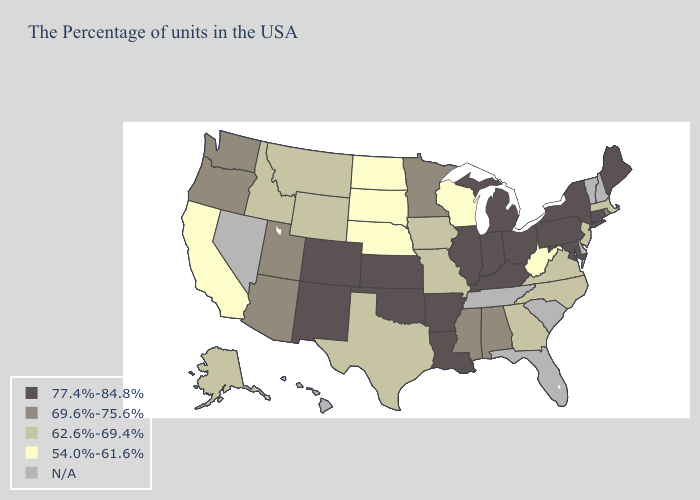Name the states that have a value in the range 77.4%-84.8%?
Short answer required. Maine, Connecticut, New York, Maryland, Pennsylvania, Ohio, Michigan, Kentucky, Indiana, Illinois, Louisiana, Arkansas, Kansas, Oklahoma, Colorado, New Mexico. What is the highest value in the South ?
Give a very brief answer. 77.4%-84.8%. What is the highest value in states that border Massachusetts?
Write a very short answer. 77.4%-84.8%. Is the legend a continuous bar?
Keep it brief. No. Name the states that have a value in the range 62.6%-69.4%?
Keep it brief. Massachusetts, New Jersey, Virginia, North Carolina, Georgia, Missouri, Iowa, Texas, Wyoming, Montana, Idaho, Alaska. What is the lowest value in states that border Delaware?
Be succinct. 62.6%-69.4%. What is the lowest value in the USA?
Be succinct. 54.0%-61.6%. Name the states that have a value in the range 62.6%-69.4%?
Write a very short answer. Massachusetts, New Jersey, Virginia, North Carolina, Georgia, Missouri, Iowa, Texas, Wyoming, Montana, Idaho, Alaska. Among the states that border North Carolina , which have the lowest value?
Be succinct. Virginia, Georgia. Which states have the lowest value in the Northeast?
Quick response, please. Massachusetts, New Jersey. Among the states that border Colorado , does Nebraska have the lowest value?
Be succinct. Yes. Among the states that border New York , does Connecticut have the highest value?
Concise answer only. Yes. Name the states that have a value in the range 77.4%-84.8%?
Concise answer only. Maine, Connecticut, New York, Maryland, Pennsylvania, Ohio, Michigan, Kentucky, Indiana, Illinois, Louisiana, Arkansas, Kansas, Oklahoma, Colorado, New Mexico. 